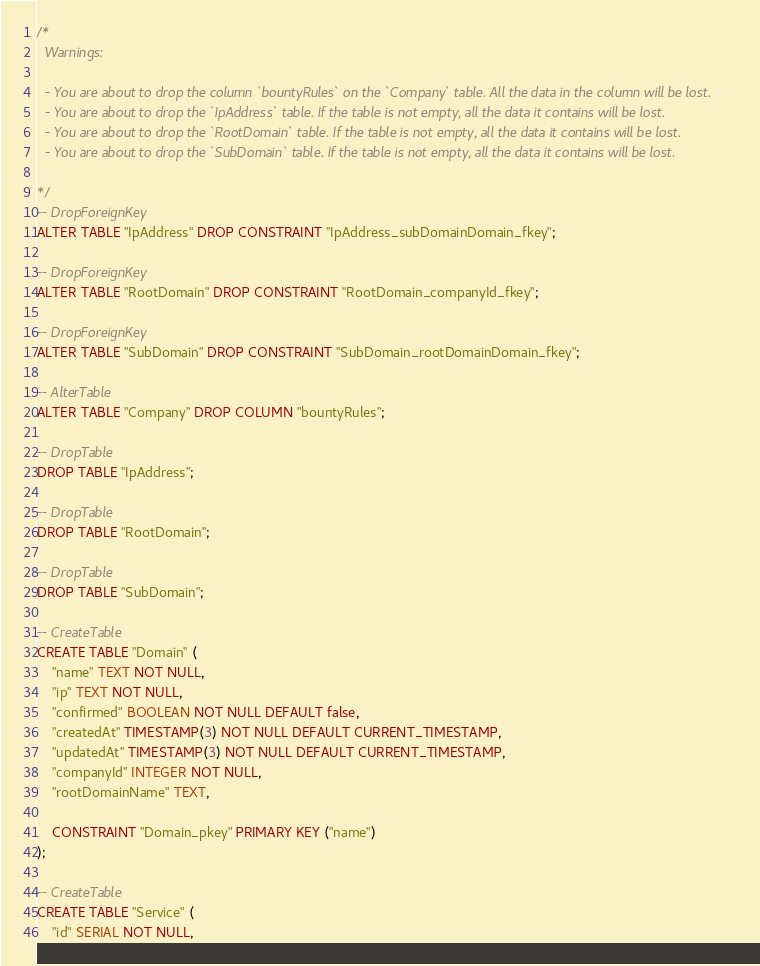Convert code to text. <code><loc_0><loc_0><loc_500><loc_500><_SQL_>/*
  Warnings:

  - You are about to drop the column `bountyRules` on the `Company` table. All the data in the column will be lost.
  - You are about to drop the `IpAddress` table. If the table is not empty, all the data it contains will be lost.
  - You are about to drop the `RootDomain` table. If the table is not empty, all the data it contains will be lost.
  - You are about to drop the `SubDomain` table. If the table is not empty, all the data it contains will be lost.

*/
-- DropForeignKey
ALTER TABLE "IpAddress" DROP CONSTRAINT "IpAddress_subDomainDomain_fkey";

-- DropForeignKey
ALTER TABLE "RootDomain" DROP CONSTRAINT "RootDomain_companyId_fkey";

-- DropForeignKey
ALTER TABLE "SubDomain" DROP CONSTRAINT "SubDomain_rootDomainDomain_fkey";

-- AlterTable
ALTER TABLE "Company" DROP COLUMN "bountyRules";

-- DropTable
DROP TABLE "IpAddress";

-- DropTable
DROP TABLE "RootDomain";

-- DropTable
DROP TABLE "SubDomain";

-- CreateTable
CREATE TABLE "Domain" (
    "name" TEXT NOT NULL,
    "ip" TEXT NOT NULL,
    "confirmed" BOOLEAN NOT NULL DEFAULT false,
    "createdAt" TIMESTAMP(3) NOT NULL DEFAULT CURRENT_TIMESTAMP,
    "updatedAt" TIMESTAMP(3) NOT NULL DEFAULT CURRENT_TIMESTAMP,
    "companyId" INTEGER NOT NULL,
    "rootDomainName" TEXT,

    CONSTRAINT "Domain_pkey" PRIMARY KEY ("name")
);

-- CreateTable
CREATE TABLE "Service" (
    "id" SERIAL NOT NULL,</code> 